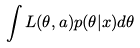Convert formula to latex. <formula><loc_0><loc_0><loc_500><loc_500>\int L ( \theta , a ) p ( \theta | x ) d \theta</formula> 